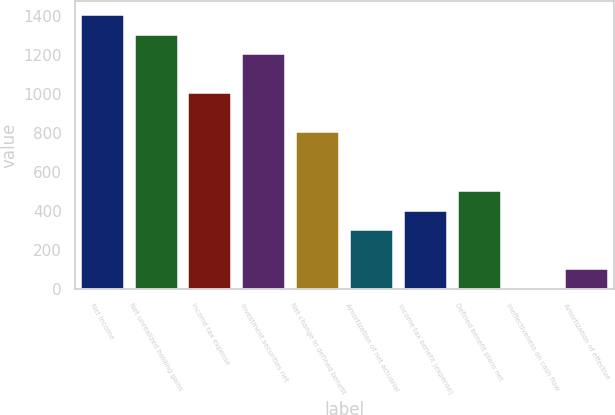Convert chart. <chart><loc_0><loc_0><loc_500><loc_500><bar_chart><fcel>Net income<fcel>Net unrealized holding gains<fcel>Income tax expense<fcel>Investment securities net<fcel>Net change in defined benefit<fcel>Amortization of net actuarial<fcel>Income tax benefit (expense)<fcel>Defined benefit plans net<fcel>Ineffectiveness on cash flow<fcel>Amortization of effective<nl><fcel>1406.26<fcel>1305.82<fcel>1004.5<fcel>1205.38<fcel>803.62<fcel>301.42<fcel>401.86<fcel>502.3<fcel>0.1<fcel>100.54<nl></chart> 